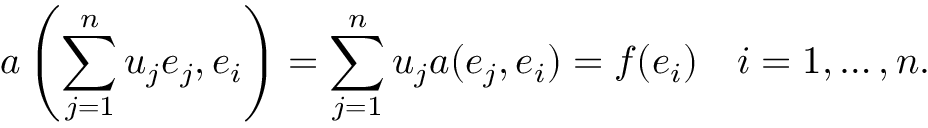<formula> <loc_0><loc_0><loc_500><loc_500>a \left ( \sum _ { j = 1 } ^ { n } u _ { j } e _ { j } , e _ { i } \right ) = \sum _ { j = 1 } ^ { n } u _ { j } a ( e _ { j } , e _ { i } ) = f ( e _ { i } ) \quad i = 1 , \dots , n .</formula> 